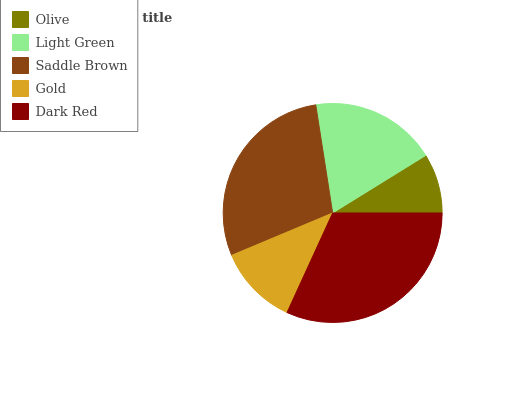Is Olive the minimum?
Answer yes or no. Yes. Is Dark Red the maximum?
Answer yes or no. Yes. Is Light Green the minimum?
Answer yes or no. No. Is Light Green the maximum?
Answer yes or no. No. Is Light Green greater than Olive?
Answer yes or no. Yes. Is Olive less than Light Green?
Answer yes or no. Yes. Is Olive greater than Light Green?
Answer yes or no. No. Is Light Green less than Olive?
Answer yes or no. No. Is Light Green the high median?
Answer yes or no. Yes. Is Light Green the low median?
Answer yes or no. Yes. Is Dark Red the high median?
Answer yes or no. No. Is Gold the low median?
Answer yes or no. No. 